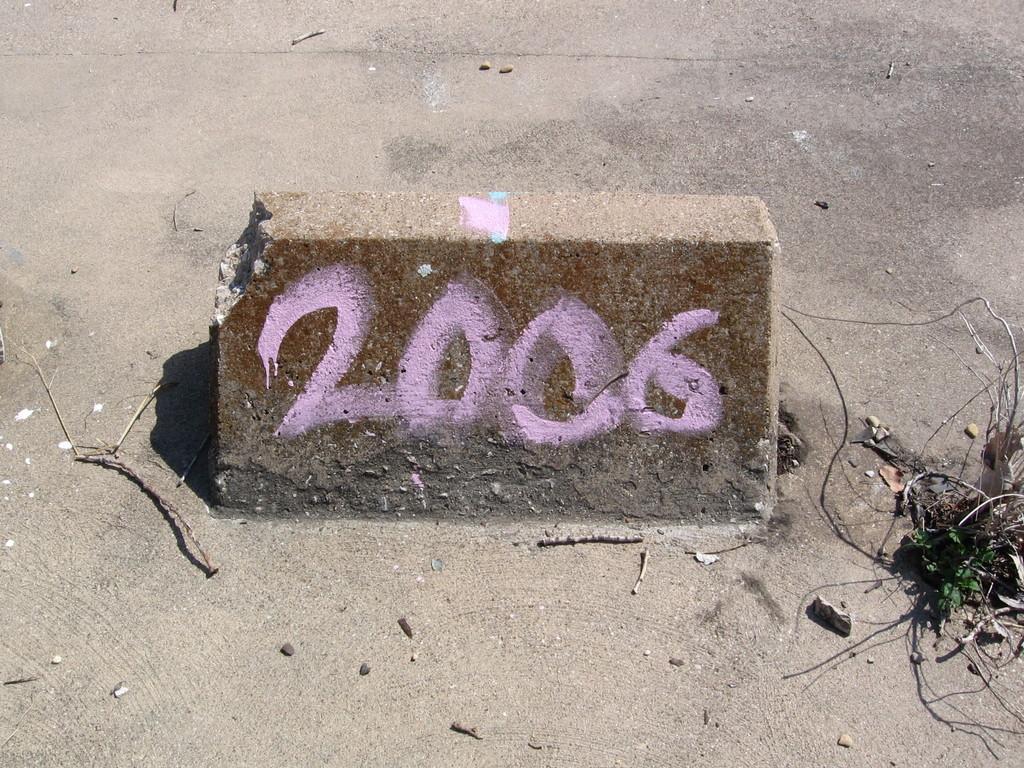Describe this image in one or two sentences. In the center of the image, we can see some text on the stone and in the background, there are twigs on the road. 